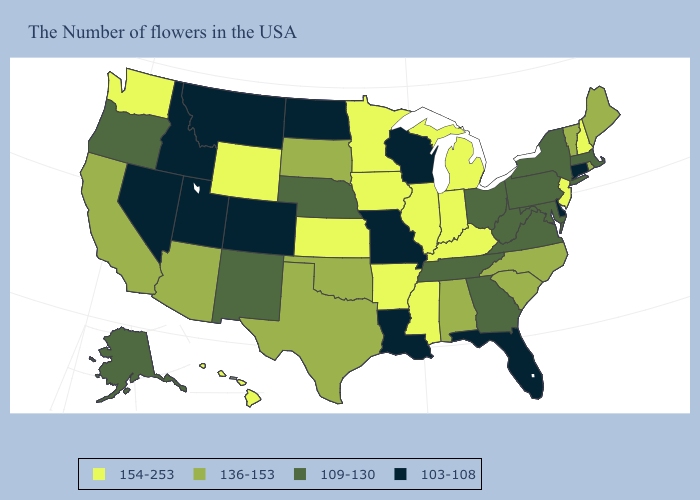Name the states that have a value in the range 103-108?
Answer briefly. Connecticut, Delaware, Florida, Wisconsin, Louisiana, Missouri, North Dakota, Colorado, Utah, Montana, Idaho, Nevada. Which states hav the highest value in the Northeast?
Short answer required. New Hampshire, New Jersey. Name the states that have a value in the range 103-108?
Answer briefly. Connecticut, Delaware, Florida, Wisconsin, Louisiana, Missouri, North Dakota, Colorado, Utah, Montana, Idaho, Nevada. What is the lowest value in states that border New Mexico?
Short answer required. 103-108. Does Utah have the highest value in the West?
Give a very brief answer. No. What is the highest value in the MidWest ?
Quick response, please. 154-253. Among the states that border Minnesota , does North Dakota have the highest value?
Keep it brief. No. Among the states that border New York , which have the highest value?
Be succinct. New Jersey. What is the lowest value in the South?
Quick response, please. 103-108. What is the value of Nebraska?
Concise answer only. 109-130. Does Tennessee have a lower value than Vermont?
Answer briefly. Yes. Name the states that have a value in the range 136-153?
Write a very short answer. Maine, Rhode Island, Vermont, North Carolina, South Carolina, Alabama, Oklahoma, Texas, South Dakota, Arizona, California. What is the value of Wyoming?
Answer briefly. 154-253. Name the states that have a value in the range 136-153?
Answer briefly. Maine, Rhode Island, Vermont, North Carolina, South Carolina, Alabama, Oklahoma, Texas, South Dakota, Arizona, California. Among the states that border Louisiana , does Texas have the lowest value?
Write a very short answer. Yes. 